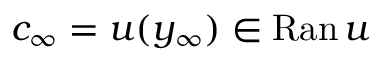<formula> <loc_0><loc_0><loc_500><loc_500>c _ { \infty } = u ( y _ { \infty } ) \in R a n \, u</formula> 